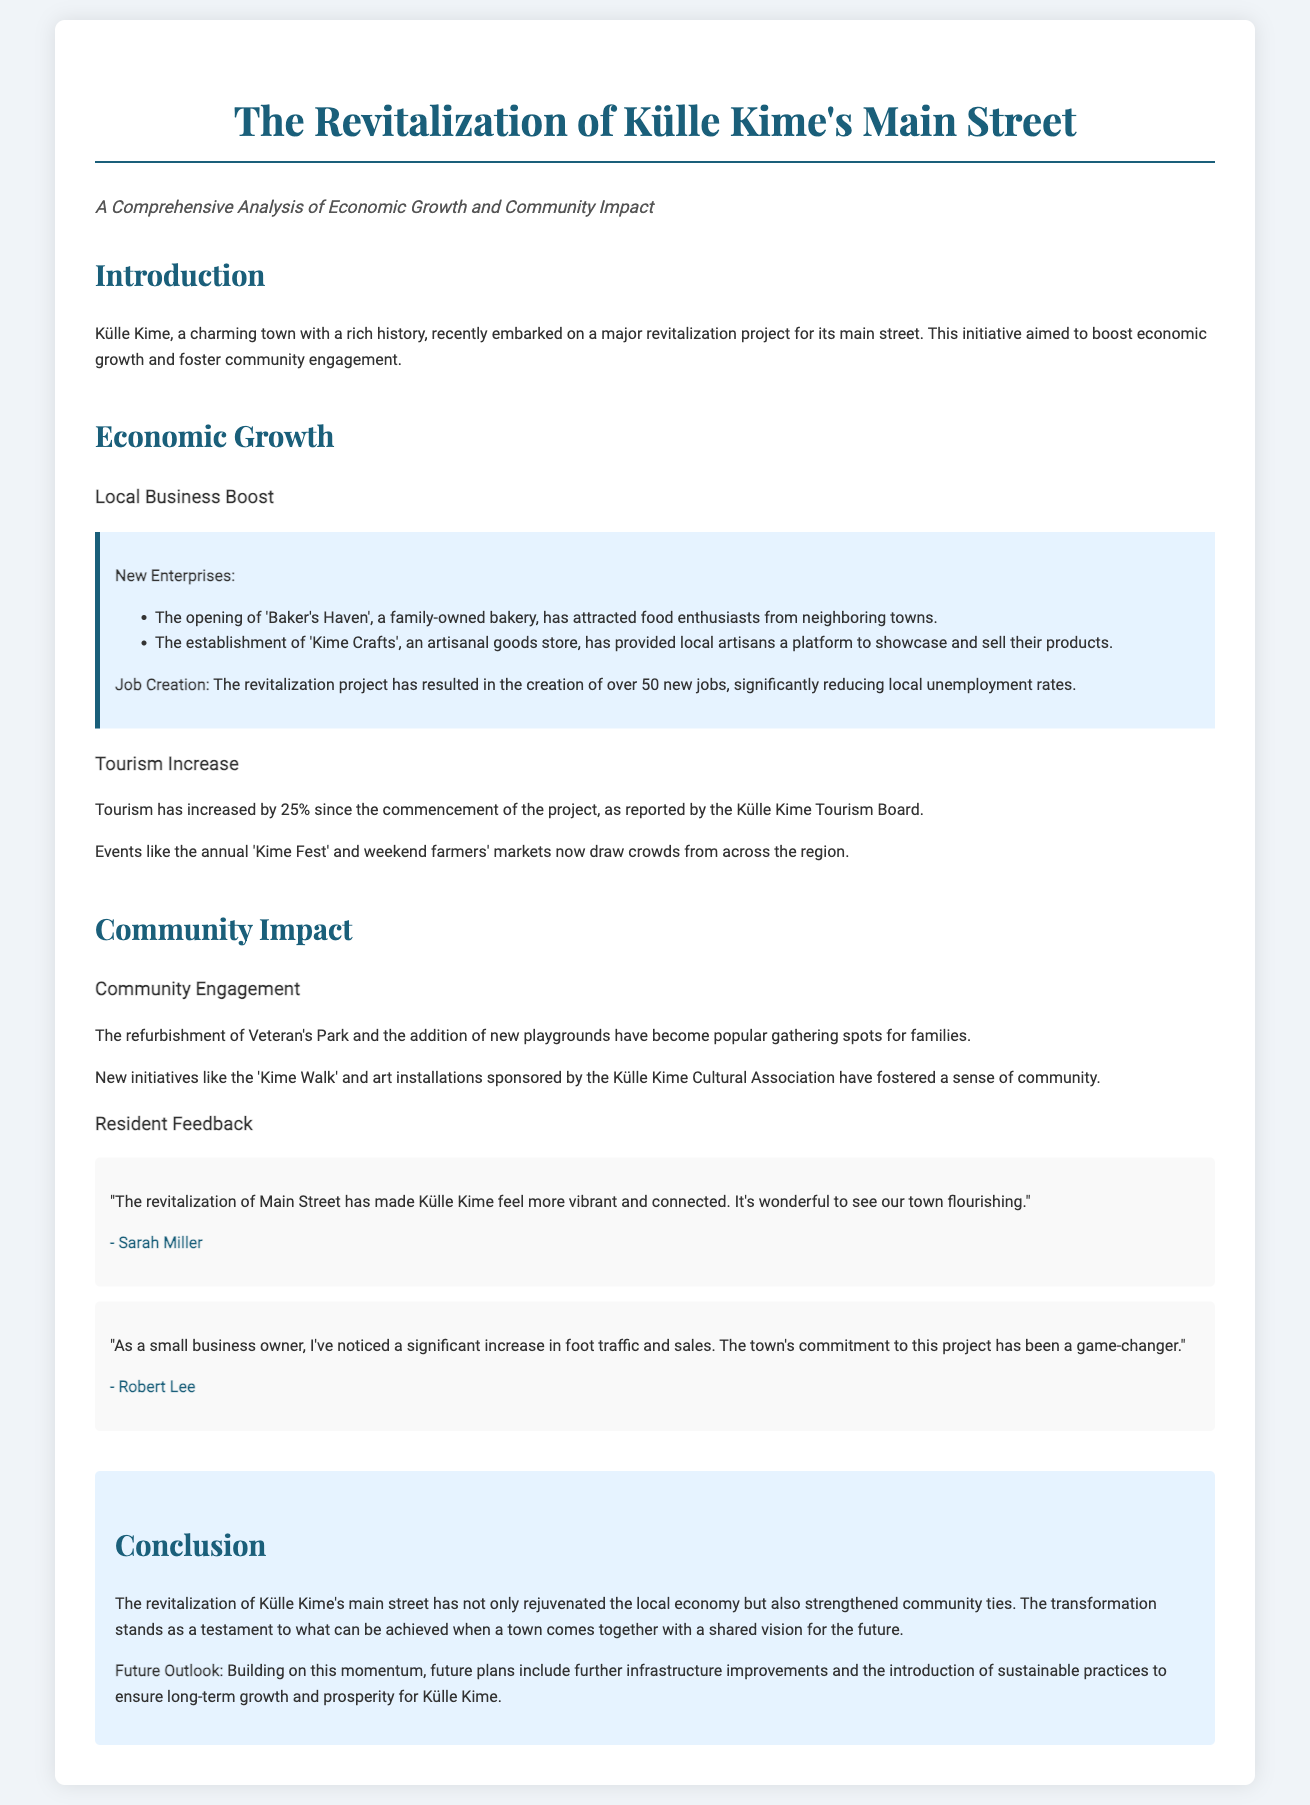What is the main goal of the revitalization project? The main goal of the revitalization project is to boost economic growth and foster community engagement.
Answer: Boost economic growth and foster community engagement How many new jobs were created as a result of the project? The document states that the revitalization project resulted in the creation of over 50 new jobs.
Answer: Over 50 new jobs What percentage has tourism increased since the project began? According to the Külle Kime Tourism Board, tourism has increased by 25% since the commencement of the project.
Answer: 25% What is one new business that opened in Külle Kime? The case study mentions 'Baker's Haven', a family-owned bakery, as one new business that opened.
Answer: Baker's Haven Which park was refurbished as part of the community improvements? The refurbishment mentioned in the document specifically refers to Veteran's Park.
Answer: Veteran's Park Who provided positive feedback about the revitalization project as a business owner? A testimonial from Robert Lee, a small business owner, provides positive feedback about the project.
Answer: Robert Lee What is a community initiative mentioned in the document? The document refers to the 'Kime Walk' as one community initiative that has fostered a sense of community.
Answer: Kime Walk What is the future outlook for Külle Kime according to the conclusion? The future outlook includes further infrastructure improvements and the introduction of sustainable practices.
Answer: Further infrastructure improvements and sustainable practices 